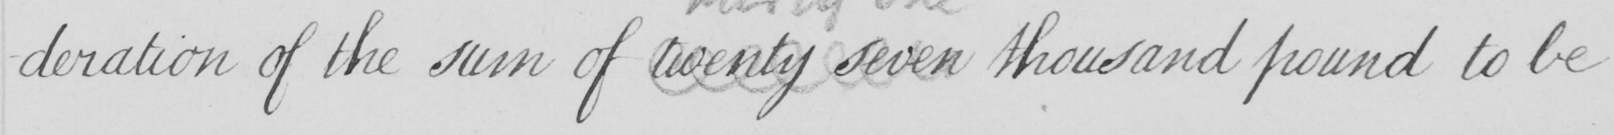What text is written in this handwritten line? -deration of the sum of twenty seven thousand pound to be 